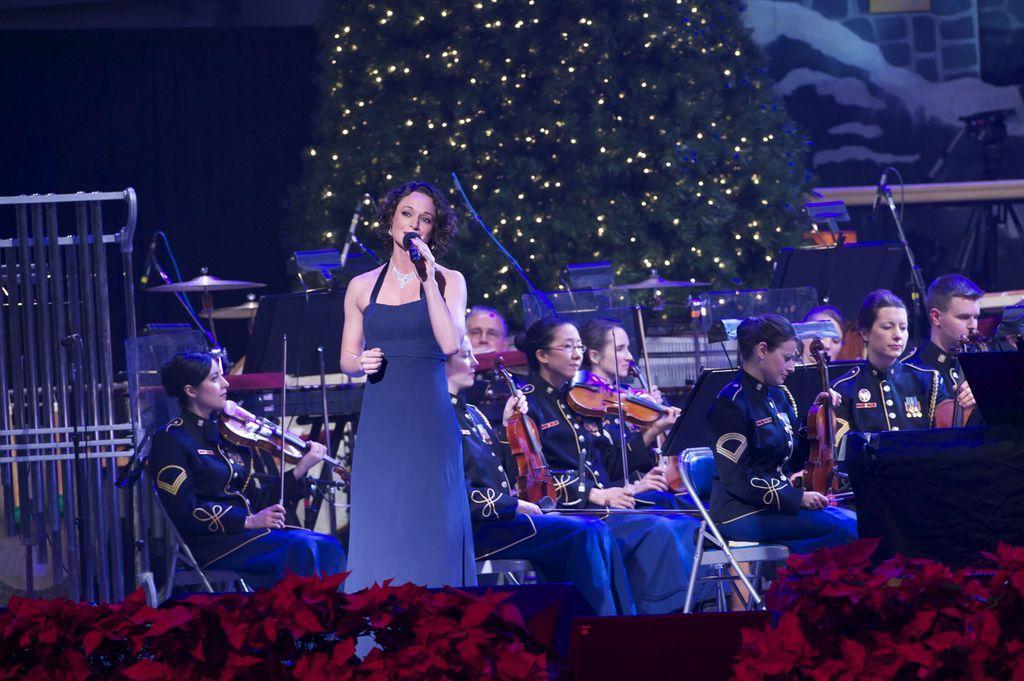In one or two sentences, can you explain what this image depicts? In this image there is a girl in the middle who is singing with the mic. In the background there are few people sitting on the chair and playing the violin. At the bottom there are red flowers. On the left side there is an iron cage. In the background there is a tree with the lights. 